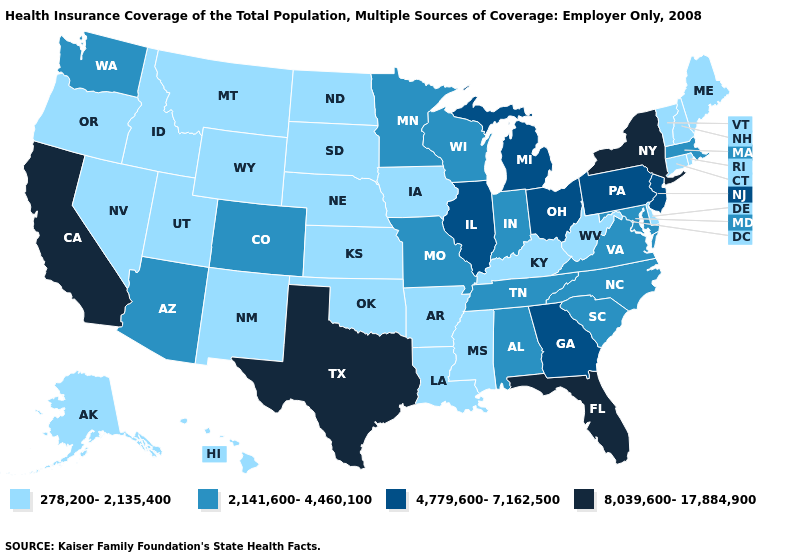What is the value of Colorado?
Be succinct. 2,141,600-4,460,100. What is the value of Indiana?
Write a very short answer. 2,141,600-4,460,100. What is the value of Virginia?
Concise answer only. 2,141,600-4,460,100. Name the states that have a value in the range 2,141,600-4,460,100?
Keep it brief. Alabama, Arizona, Colorado, Indiana, Maryland, Massachusetts, Minnesota, Missouri, North Carolina, South Carolina, Tennessee, Virginia, Washington, Wisconsin. Among the states that border Pennsylvania , does Maryland have the lowest value?
Short answer required. No. Which states have the lowest value in the Northeast?
Give a very brief answer. Connecticut, Maine, New Hampshire, Rhode Island, Vermont. Does Indiana have the lowest value in the MidWest?
Answer briefly. No. Which states have the highest value in the USA?
Quick response, please. California, Florida, New York, Texas. Does Maryland have a higher value than Missouri?
Short answer required. No. Name the states that have a value in the range 278,200-2,135,400?
Write a very short answer. Alaska, Arkansas, Connecticut, Delaware, Hawaii, Idaho, Iowa, Kansas, Kentucky, Louisiana, Maine, Mississippi, Montana, Nebraska, Nevada, New Hampshire, New Mexico, North Dakota, Oklahoma, Oregon, Rhode Island, South Dakota, Utah, Vermont, West Virginia, Wyoming. What is the value of Tennessee?
Be succinct. 2,141,600-4,460,100. How many symbols are there in the legend?
Quick response, please. 4. Name the states that have a value in the range 278,200-2,135,400?
Concise answer only. Alaska, Arkansas, Connecticut, Delaware, Hawaii, Idaho, Iowa, Kansas, Kentucky, Louisiana, Maine, Mississippi, Montana, Nebraska, Nevada, New Hampshire, New Mexico, North Dakota, Oklahoma, Oregon, Rhode Island, South Dakota, Utah, Vermont, West Virginia, Wyoming. What is the lowest value in the USA?
Be succinct. 278,200-2,135,400. Name the states that have a value in the range 8,039,600-17,884,900?
Short answer required. California, Florida, New York, Texas. 